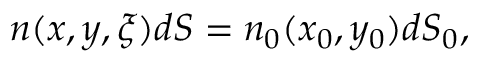Convert formula to latex. <formula><loc_0><loc_0><loc_500><loc_500>\begin{array} { r } { n ( x , y , \xi ) d S = n _ { 0 } ( x _ { 0 } , y _ { 0 } ) d S _ { 0 } , } \end{array}</formula> 